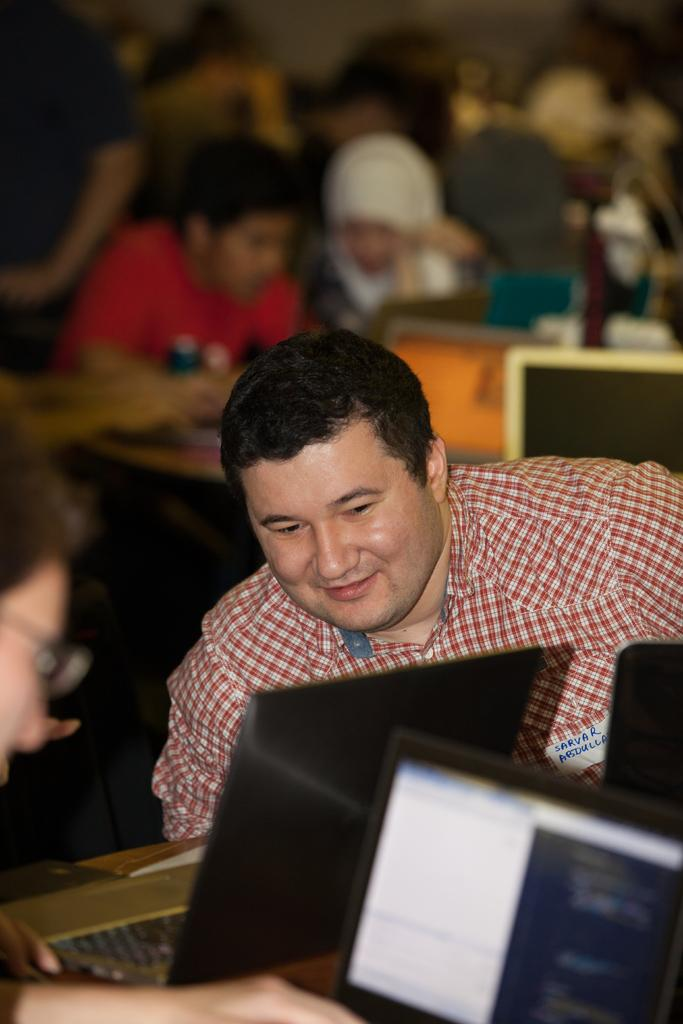What are the persons in the image doing? The persons in the image are sitting. What objects can be seen on the table in the image? There are laptops on a table in the image. What type of yarn is being used to create the fifth person in the image? There is no fifth person in the image, nor is there any yarn present. 